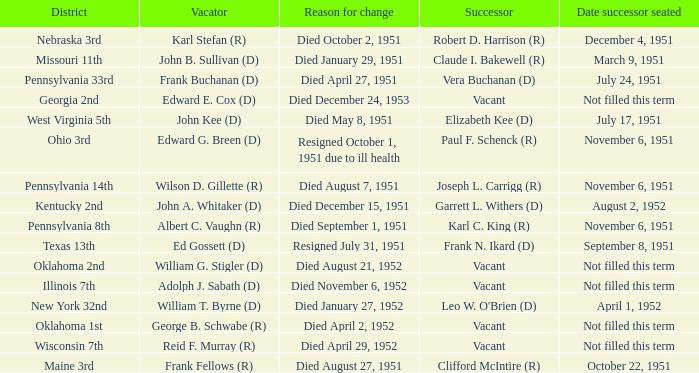Who was the successor for the Kentucky 2nd district? Garrett L. Withers (D). 